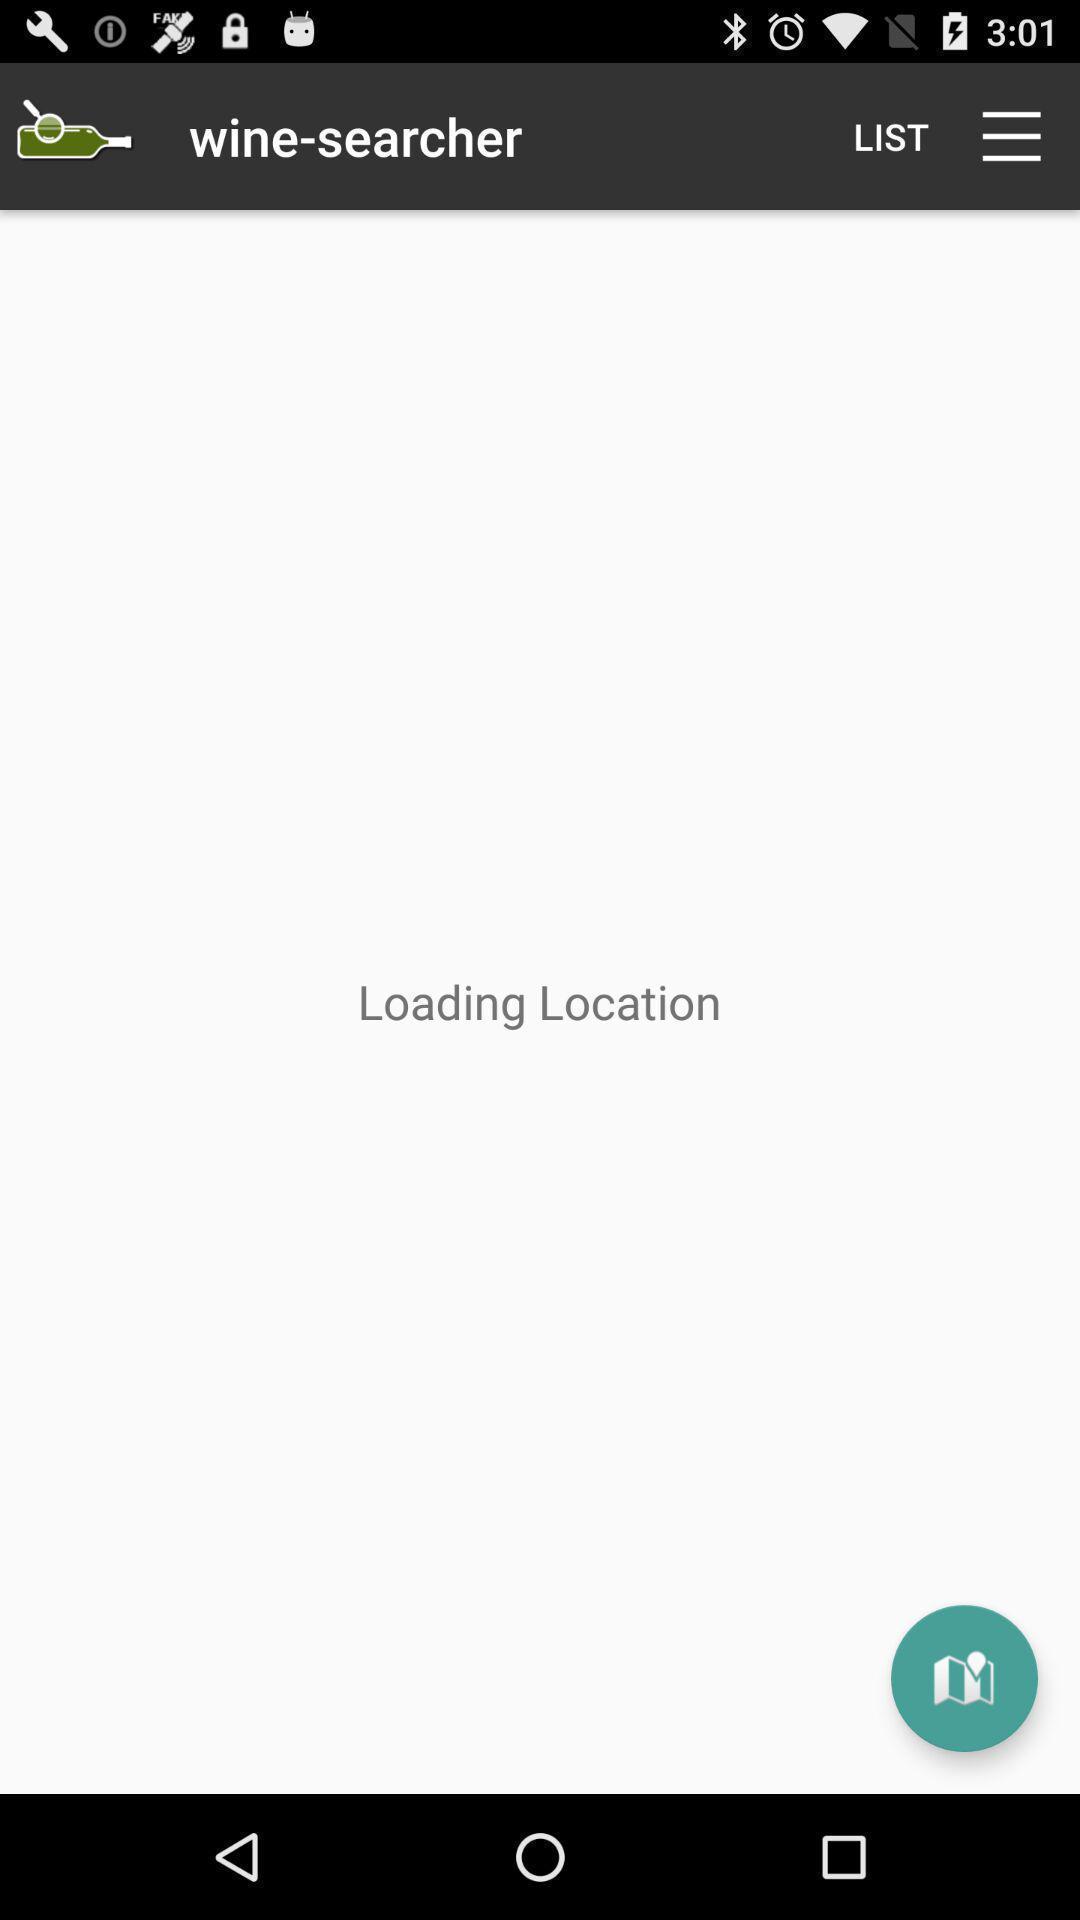Give me a narrative description of this picture. Screen displaying loading location. 